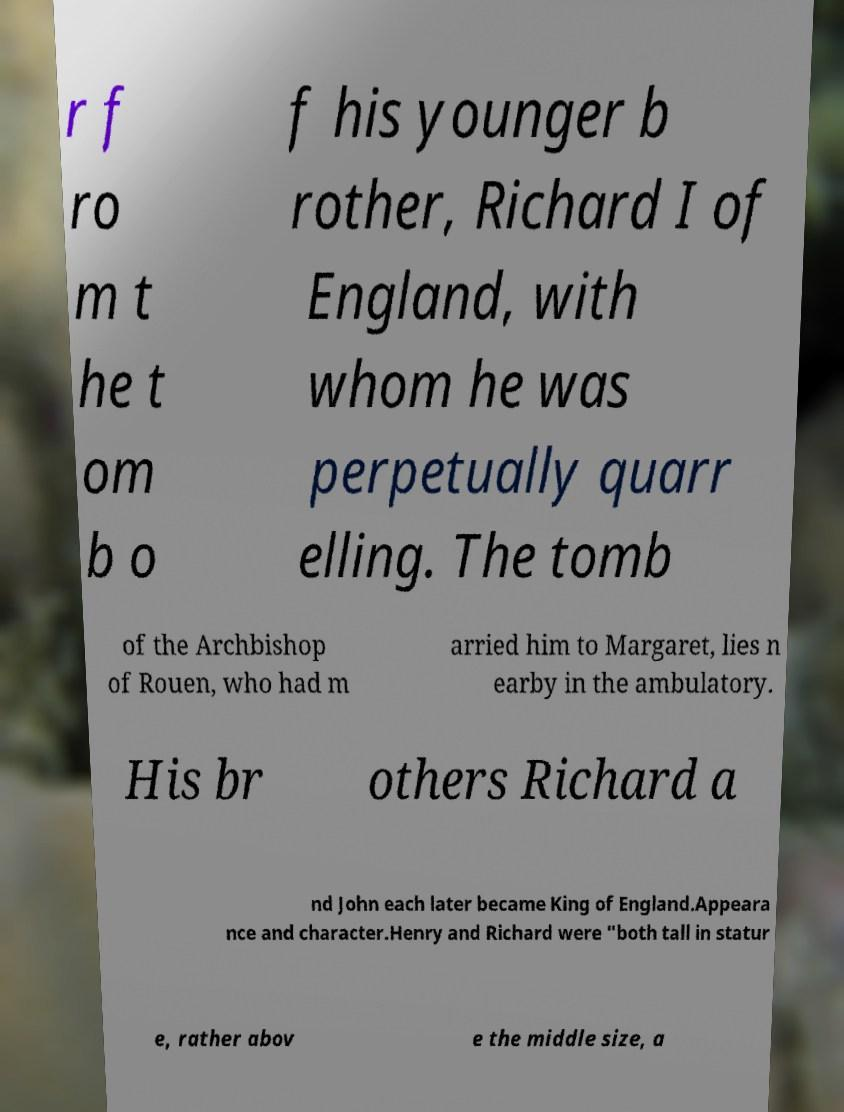Can you accurately transcribe the text from the provided image for me? r f ro m t he t om b o f his younger b rother, Richard I of England, with whom he was perpetually quarr elling. The tomb of the Archbishop of Rouen, who had m arried him to Margaret, lies n earby in the ambulatory. His br others Richard a nd John each later became King of England.Appeara nce and character.Henry and Richard were "both tall in statur e, rather abov e the middle size, a 